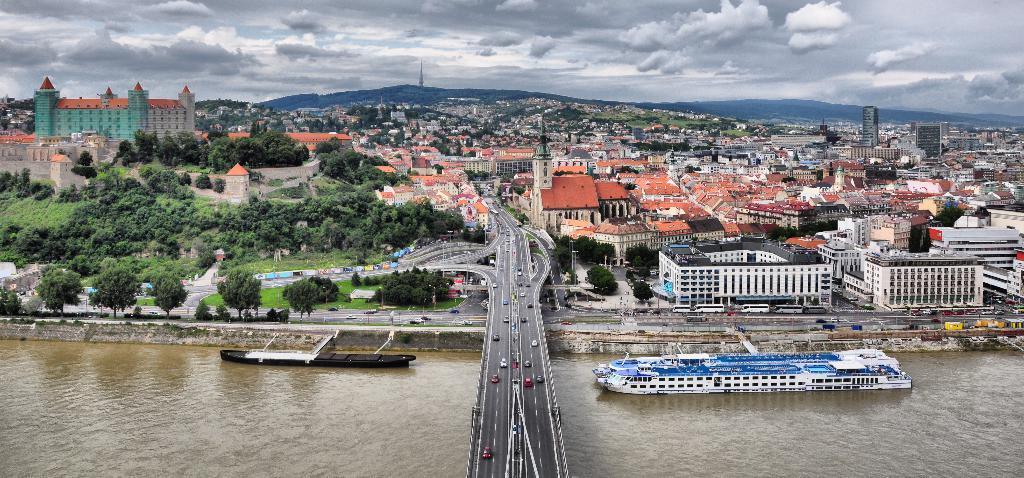Describe this image in one or two sentences. This is an outside view. At the bottom there are two boats on the water. In the background there are many buildings and trees. At the bottom there are many vehicles on the road. It is a bridge. At the top of the image, I can see the sky and clouds. 